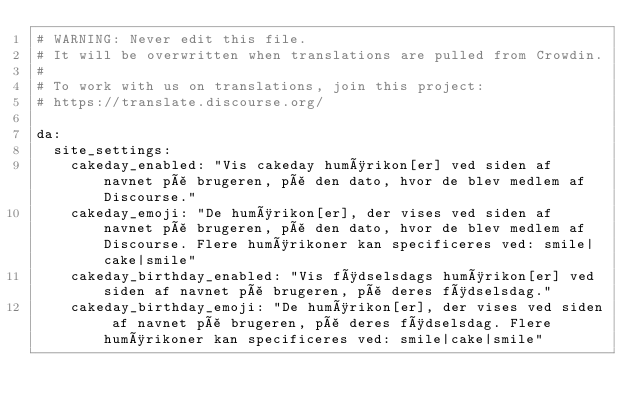Convert code to text. <code><loc_0><loc_0><loc_500><loc_500><_YAML_># WARNING: Never edit this file.
# It will be overwritten when translations are pulled from Crowdin.
#
# To work with us on translations, join this project:
# https://translate.discourse.org/

da:
  site_settings:
    cakeday_enabled: "Vis cakeday humørikon[er] ved siden af navnet på brugeren, på den dato, hvor de blev medlem af Discourse."
    cakeday_emoji: "De humørikon[er], der vises ved siden af navnet på brugeren, på den dato, hvor de blev medlem af Discourse. Flere humørikoner kan specificeres ved: smile|cake|smile"
    cakeday_birthday_enabled: "Vis fødselsdags humørikon[er] ved siden af navnet på brugeren, på deres fødselsdag."
    cakeday_birthday_emoji: "De humørikon[er], der vises ved siden af navnet på brugeren, på deres fødselsdag. Flere humørikoner kan specificeres ved: smile|cake|smile"
</code> 